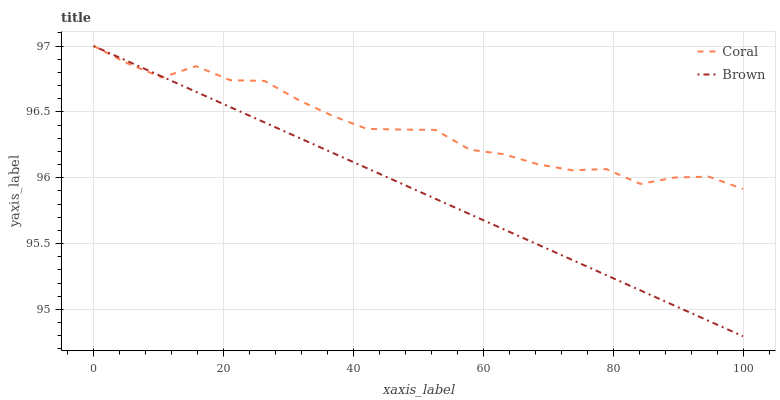Does Brown have the minimum area under the curve?
Answer yes or no. Yes. Does Coral have the maximum area under the curve?
Answer yes or no. Yes. Does Coral have the minimum area under the curve?
Answer yes or no. No. Is Brown the smoothest?
Answer yes or no. Yes. Is Coral the roughest?
Answer yes or no. Yes. Is Coral the smoothest?
Answer yes or no. No. Does Brown have the lowest value?
Answer yes or no. Yes. Does Coral have the lowest value?
Answer yes or no. No. Does Coral have the highest value?
Answer yes or no. Yes. Does Brown intersect Coral?
Answer yes or no. Yes. Is Brown less than Coral?
Answer yes or no. No. Is Brown greater than Coral?
Answer yes or no. No. 